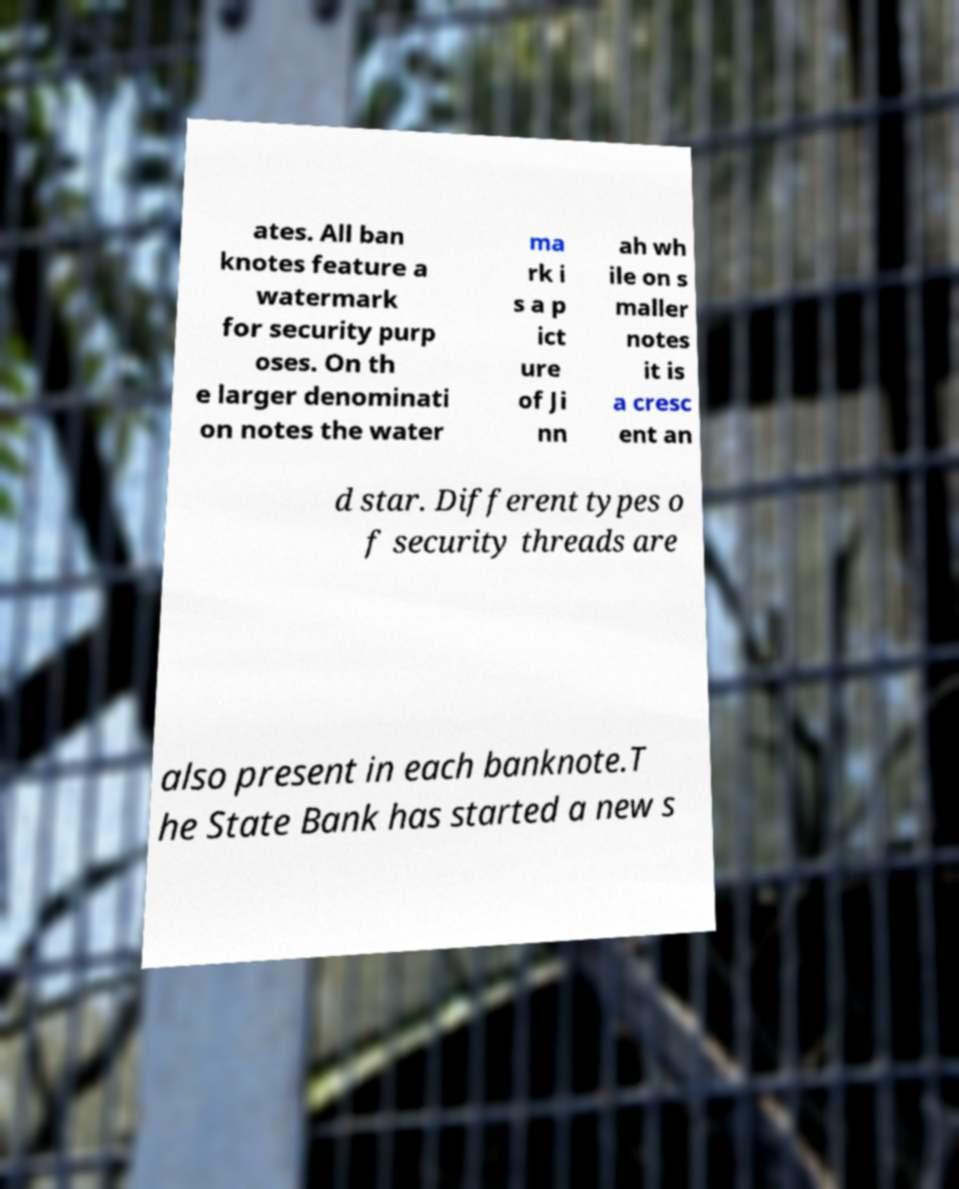There's text embedded in this image that I need extracted. Can you transcribe it verbatim? ates. All ban knotes feature a watermark for security purp oses. On th e larger denominati on notes the water ma rk i s a p ict ure of Ji nn ah wh ile on s maller notes it is a cresc ent an d star. Different types o f security threads are also present in each banknote.T he State Bank has started a new s 